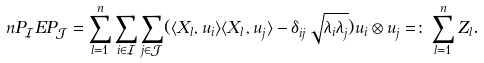<formula> <loc_0><loc_0><loc_500><loc_500>n P _ { \mathcal { I } } E P _ { \mathcal { J } } & = \sum _ { l = 1 } ^ { n } \sum _ { i \in \mathcal { I } } \sum _ { j \in \mathcal { J } } ( \langle X _ { l } , u _ { i } \rangle \langle X _ { l } , u _ { j } \rangle - \delta _ { i j } \sqrt { \lambda _ { i } \lambda _ { j } } ) u _ { i } \otimes u _ { j } = \colon \sum _ { l = 1 } ^ { n } Z _ { l } .</formula> 